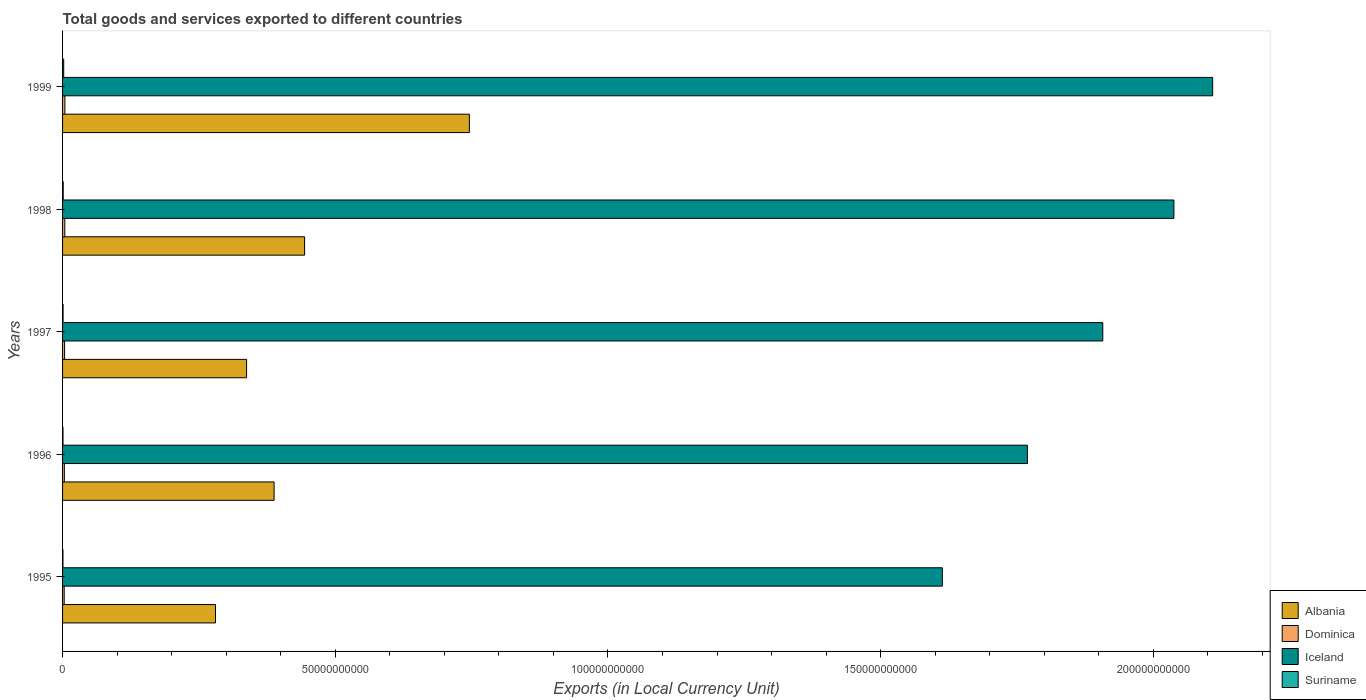How many different coloured bars are there?
Your answer should be very brief. 4. How many groups of bars are there?
Give a very brief answer. 5. Are the number of bars per tick equal to the number of legend labels?
Ensure brevity in your answer.  Yes. How many bars are there on the 3rd tick from the top?
Offer a very short reply. 4. What is the label of the 2nd group of bars from the top?
Your answer should be very brief. 1998. In how many cases, is the number of bars for a given year not equal to the number of legend labels?
Your response must be concise. 0. What is the Amount of goods and services exports in Suriname in 1999?
Provide a succinct answer. 2.07e+08. Across all years, what is the maximum Amount of goods and services exports in Dominica?
Keep it short and to the point. 4.23e+08. Across all years, what is the minimum Amount of goods and services exports in Suriname?
Your answer should be compact. 7.01e+07. In which year was the Amount of goods and services exports in Albania minimum?
Give a very brief answer. 1995. What is the total Amount of goods and services exports in Suriname in the graph?
Keep it short and to the point. 5.69e+08. What is the difference between the Amount of goods and services exports in Albania in 1998 and that in 1999?
Ensure brevity in your answer.  -3.02e+1. What is the difference between the Amount of goods and services exports in Dominica in 1996 and the Amount of goods and services exports in Suriname in 1995?
Give a very brief answer. 2.58e+08. What is the average Amount of goods and services exports in Albania per year?
Keep it short and to the point. 4.39e+1. In the year 1998, what is the difference between the Amount of goods and services exports in Suriname and Amount of goods and services exports in Iceland?
Make the answer very short. -2.04e+11. In how many years, is the Amount of goods and services exports in Albania greater than 170000000000 LCU?
Offer a terse response. 0. What is the ratio of the Amount of goods and services exports in Suriname in 1995 to that in 1997?
Keep it short and to the point. 0.75. Is the Amount of goods and services exports in Iceland in 1996 less than that in 1999?
Your answer should be compact. Yes. What is the difference between the highest and the second highest Amount of goods and services exports in Dominica?
Give a very brief answer. 1.41e+07. What is the difference between the highest and the lowest Amount of goods and services exports in Suriname?
Keep it short and to the point. 1.37e+08. In how many years, is the Amount of goods and services exports in Iceland greater than the average Amount of goods and services exports in Iceland taken over all years?
Your answer should be compact. 3. Is it the case that in every year, the sum of the Amount of goods and services exports in Suriname and Amount of goods and services exports in Dominica is greater than the sum of Amount of goods and services exports in Albania and Amount of goods and services exports in Iceland?
Ensure brevity in your answer.  No. What does the 4th bar from the top in 1997 represents?
Your answer should be very brief. Albania. What does the 3rd bar from the bottom in 1996 represents?
Offer a very short reply. Iceland. Is it the case that in every year, the sum of the Amount of goods and services exports in Suriname and Amount of goods and services exports in Albania is greater than the Amount of goods and services exports in Dominica?
Offer a terse response. Yes. How many bars are there?
Provide a succinct answer. 20. Are all the bars in the graph horizontal?
Provide a short and direct response. Yes. What is the difference between two consecutive major ticks on the X-axis?
Give a very brief answer. 5.00e+1. Where does the legend appear in the graph?
Offer a very short reply. Bottom right. How many legend labels are there?
Offer a terse response. 4. What is the title of the graph?
Provide a short and direct response. Total goods and services exported to different countries. Does "Mauritius" appear as one of the legend labels in the graph?
Provide a succinct answer. No. What is the label or title of the X-axis?
Your response must be concise. Exports (in Local Currency Unit). What is the Exports (in Local Currency Unit) in Albania in 1995?
Make the answer very short. 2.80e+1. What is the Exports (in Local Currency Unit) of Dominica in 1995?
Make the answer very short. 3.01e+08. What is the Exports (in Local Currency Unit) of Iceland in 1995?
Give a very brief answer. 1.61e+11. What is the Exports (in Local Currency Unit) of Suriname in 1995?
Your response must be concise. 7.01e+07. What is the Exports (in Local Currency Unit) in Albania in 1996?
Give a very brief answer. 3.88e+1. What is the Exports (in Local Currency Unit) in Dominica in 1996?
Give a very brief answer. 3.28e+08. What is the Exports (in Local Currency Unit) in Iceland in 1996?
Offer a terse response. 1.77e+11. What is the Exports (in Local Currency Unit) in Suriname in 1996?
Provide a short and direct response. 8.06e+07. What is the Exports (in Local Currency Unit) in Albania in 1997?
Provide a short and direct response. 3.37e+1. What is the Exports (in Local Currency Unit) of Dominica in 1997?
Offer a terse response. 3.70e+08. What is the Exports (in Local Currency Unit) in Iceland in 1997?
Provide a succinct answer. 1.91e+11. What is the Exports (in Local Currency Unit) in Suriname in 1997?
Provide a succinct answer. 9.37e+07. What is the Exports (in Local Currency Unit) of Albania in 1998?
Your answer should be compact. 4.44e+1. What is the Exports (in Local Currency Unit) of Dominica in 1998?
Make the answer very short. 4.09e+08. What is the Exports (in Local Currency Unit) in Iceland in 1998?
Ensure brevity in your answer.  2.04e+11. What is the Exports (in Local Currency Unit) in Suriname in 1998?
Provide a succinct answer. 1.18e+08. What is the Exports (in Local Currency Unit) in Albania in 1999?
Your answer should be compact. 7.46e+1. What is the Exports (in Local Currency Unit) of Dominica in 1999?
Make the answer very short. 4.23e+08. What is the Exports (in Local Currency Unit) in Iceland in 1999?
Your answer should be compact. 2.11e+11. What is the Exports (in Local Currency Unit) in Suriname in 1999?
Ensure brevity in your answer.  2.07e+08. Across all years, what is the maximum Exports (in Local Currency Unit) in Albania?
Your answer should be very brief. 7.46e+1. Across all years, what is the maximum Exports (in Local Currency Unit) of Dominica?
Provide a short and direct response. 4.23e+08. Across all years, what is the maximum Exports (in Local Currency Unit) of Iceland?
Offer a very short reply. 2.11e+11. Across all years, what is the maximum Exports (in Local Currency Unit) of Suriname?
Make the answer very short. 2.07e+08. Across all years, what is the minimum Exports (in Local Currency Unit) in Albania?
Offer a terse response. 2.80e+1. Across all years, what is the minimum Exports (in Local Currency Unit) in Dominica?
Give a very brief answer. 3.01e+08. Across all years, what is the minimum Exports (in Local Currency Unit) in Iceland?
Offer a terse response. 1.61e+11. Across all years, what is the minimum Exports (in Local Currency Unit) in Suriname?
Your answer should be compact. 7.01e+07. What is the total Exports (in Local Currency Unit) in Albania in the graph?
Keep it short and to the point. 2.20e+11. What is the total Exports (in Local Currency Unit) of Dominica in the graph?
Give a very brief answer. 1.83e+09. What is the total Exports (in Local Currency Unit) in Iceland in the graph?
Give a very brief answer. 9.44e+11. What is the total Exports (in Local Currency Unit) of Suriname in the graph?
Your answer should be very brief. 5.69e+08. What is the difference between the Exports (in Local Currency Unit) in Albania in 1995 and that in 1996?
Ensure brevity in your answer.  -1.07e+1. What is the difference between the Exports (in Local Currency Unit) of Dominica in 1995 and that in 1996?
Your answer should be compact. -2.65e+07. What is the difference between the Exports (in Local Currency Unit) in Iceland in 1995 and that in 1996?
Provide a short and direct response. -1.56e+1. What is the difference between the Exports (in Local Currency Unit) of Suriname in 1995 and that in 1996?
Keep it short and to the point. -1.05e+07. What is the difference between the Exports (in Local Currency Unit) of Albania in 1995 and that in 1997?
Keep it short and to the point. -5.70e+09. What is the difference between the Exports (in Local Currency Unit) of Dominica in 1995 and that in 1997?
Provide a short and direct response. -6.90e+07. What is the difference between the Exports (in Local Currency Unit) of Iceland in 1995 and that in 1997?
Ensure brevity in your answer.  -2.94e+1. What is the difference between the Exports (in Local Currency Unit) of Suriname in 1995 and that in 1997?
Give a very brief answer. -2.36e+07. What is the difference between the Exports (in Local Currency Unit) in Albania in 1995 and that in 1998?
Your response must be concise. -1.63e+1. What is the difference between the Exports (in Local Currency Unit) in Dominica in 1995 and that in 1998?
Your answer should be very brief. -1.08e+08. What is the difference between the Exports (in Local Currency Unit) of Iceland in 1995 and that in 1998?
Keep it short and to the point. -4.25e+1. What is the difference between the Exports (in Local Currency Unit) in Suriname in 1995 and that in 1998?
Provide a short and direct response. -4.75e+07. What is the difference between the Exports (in Local Currency Unit) in Albania in 1995 and that in 1999?
Offer a very short reply. -4.66e+1. What is the difference between the Exports (in Local Currency Unit) of Dominica in 1995 and that in 1999?
Give a very brief answer. -1.22e+08. What is the difference between the Exports (in Local Currency Unit) of Iceland in 1995 and that in 1999?
Offer a very short reply. -4.96e+1. What is the difference between the Exports (in Local Currency Unit) of Suriname in 1995 and that in 1999?
Offer a very short reply. -1.37e+08. What is the difference between the Exports (in Local Currency Unit) in Albania in 1996 and that in 1997?
Your answer should be very brief. 5.04e+09. What is the difference between the Exports (in Local Currency Unit) of Dominica in 1996 and that in 1997?
Give a very brief answer. -4.25e+07. What is the difference between the Exports (in Local Currency Unit) in Iceland in 1996 and that in 1997?
Offer a very short reply. -1.38e+1. What is the difference between the Exports (in Local Currency Unit) in Suriname in 1996 and that in 1997?
Make the answer very short. -1.31e+07. What is the difference between the Exports (in Local Currency Unit) in Albania in 1996 and that in 1998?
Your answer should be very brief. -5.59e+09. What is the difference between the Exports (in Local Currency Unit) in Dominica in 1996 and that in 1998?
Offer a very short reply. -8.16e+07. What is the difference between the Exports (in Local Currency Unit) in Iceland in 1996 and that in 1998?
Provide a succinct answer. -2.69e+1. What is the difference between the Exports (in Local Currency Unit) of Suriname in 1996 and that in 1998?
Offer a very short reply. -3.70e+07. What is the difference between the Exports (in Local Currency Unit) in Albania in 1996 and that in 1999?
Your answer should be compact. -3.58e+1. What is the difference between the Exports (in Local Currency Unit) in Dominica in 1996 and that in 1999?
Keep it short and to the point. -9.56e+07. What is the difference between the Exports (in Local Currency Unit) in Iceland in 1996 and that in 1999?
Keep it short and to the point. -3.40e+1. What is the difference between the Exports (in Local Currency Unit) in Suriname in 1996 and that in 1999?
Your answer should be compact. -1.27e+08. What is the difference between the Exports (in Local Currency Unit) in Albania in 1997 and that in 1998?
Your answer should be compact. -1.06e+1. What is the difference between the Exports (in Local Currency Unit) of Dominica in 1997 and that in 1998?
Make the answer very short. -3.90e+07. What is the difference between the Exports (in Local Currency Unit) of Iceland in 1997 and that in 1998?
Provide a short and direct response. -1.30e+1. What is the difference between the Exports (in Local Currency Unit) in Suriname in 1997 and that in 1998?
Provide a short and direct response. -2.39e+07. What is the difference between the Exports (in Local Currency Unit) of Albania in 1997 and that in 1999?
Give a very brief answer. -4.08e+1. What is the difference between the Exports (in Local Currency Unit) of Dominica in 1997 and that in 1999?
Keep it short and to the point. -5.31e+07. What is the difference between the Exports (in Local Currency Unit) in Iceland in 1997 and that in 1999?
Offer a terse response. -2.02e+1. What is the difference between the Exports (in Local Currency Unit) in Suriname in 1997 and that in 1999?
Ensure brevity in your answer.  -1.14e+08. What is the difference between the Exports (in Local Currency Unit) in Albania in 1998 and that in 1999?
Ensure brevity in your answer.  -3.02e+1. What is the difference between the Exports (in Local Currency Unit) in Dominica in 1998 and that in 1999?
Keep it short and to the point. -1.41e+07. What is the difference between the Exports (in Local Currency Unit) in Iceland in 1998 and that in 1999?
Make the answer very short. -7.11e+09. What is the difference between the Exports (in Local Currency Unit) in Suriname in 1998 and that in 1999?
Offer a very short reply. -8.98e+07. What is the difference between the Exports (in Local Currency Unit) of Albania in 1995 and the Exports (in Local Currency Unit) of Dominica in 1996?
Your answer should be very brief. 2.77e+1. What is the difference between the Exports (in Local Currency Unit) in Albania in 1995 and the Exports (in Local Currency Unit) in Iceland in 1996?
Ensure brevity in your answer.  -1.49e+11. What is the difference between the Exports (in Local Currency Unit) in Albania in 1995 and the Exports (in Local Currency Unit) in Suriname in 1996?
Make the answer very short. 2.80e+1. What is the difference between the Exports (in Local Currency Unit) of Dominica in 1995 and the Exports (in Local Currency Unit) of Iceland in 1996?
Your answer should be compact. -1.77e+11. What is the difference between the Exports (in Local Currency Unit) of Dominica in 1995 and the Exports (in Local Currency Unit) of Suriname in 1996?
Your response must be concise. 2.21e+08. What is the difference between the Exports (in Local Currency Unit) of Iceland in 1995 and the Exports (in Local Currency Unit) of Suriname in 1996?
Provide a succinct answer. 1.61e+11. What is the difference between the Exports (in Local Currency Unit) in Albania in 1995 and the Exports (in Local Currency Unit) in Dominica in 1997?
Ensure brevity in your answer.  2.77e+1. What is the difference between the Exports (in Local Currency Unit) of Albania in 1995 and the Exports (in Local Currency Unit) of Iceland in 1997?
Offer a very short reply. -1.63e+11. What is the difference between the Exports (in Local Currency Unit) of Albania in 1995 and the Exports (in Local Currency Unit) of Suriname in 1997?
Your answer should be very brief. 2.79e+1. What is the difference between the Exports (in Local Currency Unit) of Dominica in 1995 and the Exports (in Local Currency Unit) of Iceland in 1997?
Offer a terse response. -1.90e+11. What is the difference between the Exports (in Local Currency Unit) of Dominica in 1995 and the Exports (in Local Currency Unit) of Suriname in 1997?
Offer a terse response. 2.08e+08. What is the difference between the Exports (in Local Currency Unit) of Iceland in 1995 and the Exports (in Local Currency Unit) of Suriname in 1997?
Offer a very short reply. 1.61e+11. What is the difference between the Exports (in Local Currency Unit) of Albania in 1995 and the Exports (in Local Currency Unit) of Dominica in 1998?
Provide a short and direct response. 2.76e+1. What is the difference between the Exports (in Local Currency Unit) of Albania in 1995 and the Exports (in Local Currency Unit) of Iceland in 1998?
Offer a terse response. -1.76e+11. What is the difference between the Exports (in Local Currency Unit) of Albania in 1995 and the Exports (in Local Currency Unit) of Suriname in 1998?
Provide a succinct answer. 2.79e+1. What is the difference between the Exports (in Local Currency Unit) of Dominica in 1995 and the Exports (in Local Currency Unit) of Iceland in 1998?
Make the answer very short. -2.03e+11. What is the difference between the Exports (in Local Currency Unit) in Dominica in 1995 and the Exports (in Local Currency Unit) in Suriname in 1998?
Your response must be concise. 1.84e+08. What is the difference between the Exports (in Local Currency Unit) in Iceland in 1995 and the Exports (in Local Currency Unit) in Suriname in 1998?
Provide a succinct answer. 1.61e+11. What is the difference between the Exports (in Local Currency Unit) of Albania in 1995 and the Exports (in Local Currency Unit) of Dominica in 1999?
Offer a terse response. 2.76e+1. What is the difference between the Exports (in Local Currency Unit) in Albania in 1995 and the Exports (in Local Currency Unit) in Iceland in 1999?
Keep it short and to the point. -1.83e+11. What is the difference between the Exports (in Local Currency Unit) in Albania in 1995 and the Exports (in Local Currency Unit) in Suriname in 1999?
Offer a very short reply. 2.78e+1. What is the difference between the Exports (in Local Currency Unit) in Dominica in 1995 and the Exports (in Local Currency Unit) in Iceland in 1999?
Your response must be concise. -2.11e+11. What is the difference between the Exports (in Local Currency Unit) in Dominica in 1995 and the Exports (in Local Currency Unit) in Suriname in 1999?
Make the answer very short. 9.40e+07. What is the difference between the Exports (in Local Currency Unit) of Iceland in 1995 and the Exports (in Local Currency Unit) of Suriname in 1999?
Your response must be concise. 1.61e+11. What is the difference between the Exports (in Local Currency Unit) in Albania in 1996 and the Exports (in Local Currency Unit) in Dominica in 1997?
Give a very brief answer. 3.84e+1. What is the difference between the Exports (in Local Currency Unit) in Albania in 1996 and the Exports (in Local Currency Unit) in Iceland in 1997?
Your response must be concise. -1.52e+11. What is the difference between the Exports (in Local Currency Unit) in Albania in 1996 and the Exports (in Local Currency Unit) in Suriname in 1997?
Provide a succinct answer. 3.87e+1. What is the difference between the Exports (in Local Currency Unit) in Dominica in 1996 and the Exports (in Local Currency Unit) in Iceland in 1997?
Provide a succinct answer. -1.90e+11. What is the difference between the Exports (in Local Currency Unit) of Dominica in 1996 and the Exports (in Local Currency Unit) of Suriname in 1997?
Make the answer very short. 2.34e+08. What is the difference between the Exports (in Local Currency Unit) of Iceland in 1996 and the Exports (in Local Currency Unit) of Suriname in 1997?
Make the answer very short. 1.77e+11. What is the difference between the Exports (in Local Currency Unit) in Albania in 1996 and the Exports (in Local Currency Unit) in Dominica in 1998?
Give a very brief answer. 3.84e+1. What is the difference between the Exports (in Local Currency Unit) in Albania in 1996 and the Exports (in Local Currency Unit) in Iceland in 1998?
Ensure brevity in your answer.  -1.65e+11. What is the difference between the Exports (in Local Currency Unit) of Albania in 1996 and the Exports (in Local Currency Unit) of Suriname in 1998?
Your response must be concise. 3.87e+1. What is the difference between the Exports (in Local Currency Unit) in Dominica in 1996 and the Exports (in Local Currency Unit) in Iceland in 1998?
Your answer should be compact. -2.03e+11. What is the difference between the Exports (in Local Currency Unit) in Dominica in 1996 and the Exports (in Local Currency Unit) in Suriname in 1998?
Your response must be concise. 2.10e+08. What is the difference between the Exports (in Local Currency Unit) of Iceland in 1996 and the Exports (in Local Currency Unit) of Suriname in 1998?
Ensure brevity in your answer.  1.77e+11. What is the difference between the Exports (in Local Currency Unit) of Albania in 1996 and the Exports (in Local Currency Unit) of Dominica in 1999?
Keep it short and to the point. 3.84e+1. What is the difference between the Exports (in Local Currency Unit) of Albania in 1996 and the Exports (in Local Currency Unit) of Iceland in 1999?
Your answer should be very brief. -1.72e+11. What is the difference between the Exports (in Local Currency Unit) of Albania in 1996 and the Exports (in Local Currency Unit) of Suriname in 1999?
Provide a succinct answer. 3.86e+1. What is the difference between the Exports (in Local Currency Unit) in Dominica in 1996 and the Exports (in Local Currency Unit) in Iceland in 1999?
Provide a short and direct response. -2.11e+11. What is the difference between the Exports (in Local Currency Unit) of Dominica in 1996 and the Exports (in Local Currency Unit) of Suriname in 1999?
Give a very brief answer. 1.20e+08. What is the difference between the Exports (in Local Currency Unit) of Iceland in 1996 and the Exports (in Local Currency Unit) of Suriname in 1999?
Ensure brevity in your answer.  1.77e+11. What is the difference between the Exports (in Local Currency Unit) of Albania in 1997 and the Exports (in Local Currency Unit) of Dominica in 1998?
Provide a succinct answer. 3.33e+1. What is the difference between the Exports (in Local Currency Unit) of Albania in 1997 and the Exports (in Local Currency Unit) of Iceland in 1998?
Provide a short and direct response. -1.70e+11. What is the difference between the Exports (in Local Currency Unit) of Albania in 1997 and the Exports (in Local Currency Unit) of Suriname in 1998?
Give a very brief answer. 3.36e+1. What is the difference between the Exports (in Local Currency Unit) in Dominica in 1997 and the Exports (in Local Currency Unit) in Iceland in 1998?
Your response must be concise. -2.03e+11. What is the difference between the Exports (in Local Currency Unit) of Dominica in 1997 and the Exports (in Local Currency Unit) of Suriname in 1998?
Your answer should be compact. 2.53e+08. What is the difference between the Exports (in Local Currency Unit) in Iceland in 1997 and the Exports (in Local Currency Unit) in Suriname in 1998?
Keep it short and to the point. 1.91e+11. What is the difference between the Exports (in Local Currency Unit) of Albania in 1997 and the Exports (in Local Currency Unit) of Dominica in 1999?
Offer a terse response. 3.33e+1. What is the difference between the Exports (in Local Currency Unit) in Albania in 1997 and the Exports (in Local Currency Unit) in Iceland in 1999?
Ensure brevity in your answer.  -1.77e+11. What is the difference between the Exports (in Local Currency Unit) of Albania in 1997 and the Exports (in Local Currency Unit) of Suriname in 1999?
Provide a succinct answer. 3.35e+1. What is the difference between the Exports (in Local Currency Unit) of Dominica in 1997 and the Exports (in Local Currency Unit) of Iceland in 1999?
Make the answer very short. -2.10e+11. What is the difference between the Exports (in Local Currency Unit) of Dominica in 1997 and the Exports (in Local Currency Unit) of Suriname in 1999?
Your answer should be very brief. 1.63e+08. What is the difference between the Exports (in Local Currency Unit) of Iceland in 1997 and the Exports (in Local Currency Unit) of Suriname in 1999?
Provide a succinct answer. 1.91e+11. What is the difference between the Exports (in Local Currency Unit) in Albania in 1998 and the Exports (in Local Currency Unit) in Dominica in 1999?
Your response must be concise. 4.40e+1. What is the difference between the Exports (in Local Currency Unit) in Albania in 1998 and the Exports (in Local Currency Unit) in Iceland in 1999?
Provide a succinct answer. -1.66e+11. What is the difference between the Exports (in Local Currency Unit) of Albania in 1998 and the Exports (in Local Currency Unit) of Suriname in 1999?
Provide a short and direct response. 4.42e+1. What is the difference between the Exports (in Local Currency Unit) of Dominica in 1998 and the Exports (in Local Currency Unit) of Iceland in 1999?
Ensure brevity in your answer.  -2.10e+11. What is the difference between the Exports (in Local Currency Unit) of Dominica in 1998 and the Exports (in Local Currency Unit) of Suriname in 1999?
Ensure brevity in your answer.  2.02e+08. What is the difference between the Exports (in Local Currency Unit) of Iceland in 1998 and the Exports (in Local Currency Unit) of Suriname in 1999?
Ensure brevity in your answer.  2.04e+11. What is the average Exports (in Local Currency Unit) in Albania per year?
Give a very brief answer. 4.39e+1. What is the average Exports (in Local Currency Unit) of Dominica per year?
Provide a succinct answer. 3.66e+08. What is the average Exports (in Local Currency Unit) in Iceland per year?
Offer a very short reply. 1.89e+11. What is the average Exports (in Local Currency Unit) of Suriname per year?
Give a very brief answer. 1.14e+08. In the year 1995, what is the difference between the Exports (in Local Currency Unit) of Albania and Exports (in Local Currency Unit) of Dominica?
Provide a short and direct response. 2.77e+1. In the year 1995, what is the difference between the Exports (in Local Currency Unit) in Albania and Exports (in Local Currency Unit) in Iceland?
Your answer should be compact. -1.33e+11. In the year 1995, what is the difference between the Exports (in Local Currency Unit) of Albania and Exports (in Local Currency Unit) of Suriname?
Your response must be concise. 2.80e+1. In the year 1995, what is the difference between the Exports (in Local Currency Unit) of Dominica and Exports (in Local Currency Unit) of Iceland?
Keep it short and to the point. -1.61e+11. In the year 1995, what is the difference between the Exports (in Local Currency Unit) in Dominica and Exports (in Local Currency Unit) in Suriname?
Provide a succinct answer. 2.31e+08. In the year 1995, what is the difference between the Exports (in Local Currency Unit) of Iceland and Exports (in Local Currency Unit) of Suriname?
Give a very brief answer. 1.61e+11. In the year 1996, what is the difference between the Exports (in Local Currency Unit) of Albania and Exports (in Local Currency Unit) of Dominica?
Your answer should be very brief. 3.85e+1. In the year 1996, what is the difference between the Exports (in Local Currency Unit) of Albania and Exports (in Local Currency Unit) of Iceland?
Provide a succinct answer. -1.38e+11. In the year 1996, what is the difference between the Exports (in Local Currency Unit) in Albania and Exports (in Local Currency Unit) in Suriname?
Offer a terse response. 3.87e+1. In the year 1996, what is the difference between the Exports (in Local Currency Unit) in Dominica and Exports (in Local Currency Unit) in Iceland?
Offer a terse response. -1.77e+11. In the year 1996, what is the difference between the Exports (in Local Currency Unit) of Dominica and Exports (in Local Currency Unit) of Suriname?
Provide a short and direct response. 2.47e+08. In the year 1996, what is the difference between the Exports (in Local Currency Unit) of Iceland and Exports (in Local Currency Unit) of Suriname?
Your answer should be compact. 1.77e+11. In the year 1997, what is the difference between the Exports (in Local Currency Unit) of Albania and Exports (in Local Currency Unit) of Dominica?
Give a very brief answer. 3.34e+1. In the year 1997, what is the difference between the Exports (in Local Currency Unit) of Albania and Exports (in Local Currency Unit) of Iceland?
Provide a short and direct response. -1.57e+11. In the year 1997, what is the difference between the Exports (in Local Currency Unit) in Albania and Exports (in Local Currency Unit) in Suriname?
Offer a terse response. 3.36e+1. In the year 1997, what is the difference between the Exports (in Local Currency Unit) in Dominica and Exports (in Local Currency Unit) in Iceland?
Ensure brevity in your answer.  -1.90e+11. In the year 1997, what is the difference between the Exports (in Local Currency Unit) of Dominica and Exports (in Local Currency Unit) of Suriname?
Your response must be concise. 2.77e+08. In the year 1997, what is the difference between the Exports (in Local Currency Unit) in Iceland and Exports (in Local Currency Unit) in Suriname?
Offer a terse response. 1.91e+11. In the year 1998, what is the difference between the Exports (in Local Currency Unit) in Albania and Exports (in Local Currency Unit) in Dominica?
Offer a very short reply. 4.40e+1. In the year 1998, what is the difference between the Exports (in Local Currency Unit) of Albania and Exports (in Local Currency Unit) of Iceland?
Your answer should be compact. -1.59e+11. In the year 1998, what is the difference between the Exports (in Local Currency Unit) in Albania and Exports (in Local Currency Unit) in Suriname?
Provide a short and direct response. 4.43e+1. In the year 1998, what is the difference between the Exports (in Local Currency Unit) in Dominica and Exports (in Local Currency Unit) in Iceland?
Your answer should be very brief. -2.03e+11. In the year 1998, what is the difference between the Exports (in Local Currency Unit) in Dominica and Exports (in Local Currency Unit) in Suriname?
Provide a short and direct response. 2.92e+08. In the year 1998, what is the difference between the Exports (in Local Currency Unit) of Iceland and Exports (in Local Currency Unit) of Suriname?
Your response must be concise. 2.04e+11. In the year 1999, what is the difference between the Exports (in Local Currency Unit) in Albania and Exports (in Local Currency Unit) in Dominica?
Your answer should be very brief. 7.42e+1. In the year 1999, what is the difference between the Exports (in Local Currency Unit) of Albania and Exports (in Local Currency Unit) of Iceland?
Make the answer very short. -1.36e+11. In the year 1999, what is the difference between the Exports (in Local Currency Unit) of Albania and Exports (in Local Currency Unit) of Suriname?
Your response must be concise. 7.44e+1. In the year 1999, what is the difference between the Exports (in Local Currency Unit) of Dominica and Exports (in Local Currency Unit) of Iceland?
Offer a terse response. -2.10e+11. In the year 1999, what is the difference between the Exports (in Local Currency Unit) in Dominica and Exports (in Local Currency Unit) in Suriname?
Provide a short and direct response. 2.16e+08. In the year 1999, what is the difference between the Exports (in Local Currency Unit) in Iceland and Exports (in Local Currency Unit) in Suriname?
Ensure brevity in your answer.  2.11e+11. What is the ratio of the Exports (in Local Currency Unit) of Albania in 1995 to that in 1996?
Your response must be concise. 0.72. What is the ratio of the Exports (in Local Currency Unit) of Dominica in 1995 to that in 1996?
Your answer should be compact. 0.92. What is the ratio of the Exports (in Local Currency Unit) of Iceland in 1995 to that in 1996?
Your answer should be compact. 0.91. What is the ratio of the Exports (in Local Currency Unit) of Suriname in 1995 to that in 1996?
Offer a terse response. 0.87. What is the ratio of the Exports (in Local Currency Unit) of Albania in 1995 to that in 1997?
Keep it short and to the point. 0.83. What is the ratio of the Exports (in Local Currency Unit) in Dominica in 1995 to that in 1997?
Your response must be concise. 0.81. What is the ratio of the Exports (in Local Currency Unit) of Iceland in 1995 to that in 1997?
Offer a terse response. 0.85. What is the ratio of the Exports (in Local Currency Unit) of Suriname in 1995 to that in 1997?
Your answer should be compact. 0.75. What is the ratio of the Exports (in Local Currency Unit) in Albania in 1995 to that in 1998?
Make the answer very short. 0.63. What is the ratio of the Exports (in Local Currency Unit) of Dominica in 1995 to that in 1998?
Offer a very short reply. 0.74. What is the ratio of the Exports (in Local Currency Unit) in Iceland in 1995 to that in 1998?
Provide a short and direct response. 0.79. What is the ratio of the Exports (in Local Currency Unit) of Suriname in 1995 to that in 1998?
Offer a terse response. 0.6. What is the ratio of the Exports (in Local Currency Unit) in Albania in 1995 to that in 1999?
Give a very brief answer. 0.38. What is the ratio of the Exports (in Local Currency Unit) in Dominica in 1995 to that in 1999?
Keep it short and to the point. 0.71. What is the ratio of the Exports (in Local Currency Unit) of Iceland in 1995 to that in 1999?
Offer a very short reply. 0.77. What is the ratio of the Exports (in Local Currency Unit) of Suriname in 1995 to that in 1999?
Your response must be concise. 0.34. What is the ratio of the Exports (in Local Currency Unit) in Albania in 1996 to that in 1997?
Offer a very short reply. 1.15. What is the ratio of the Exports (in Local Currency Unit) of Dominica in 1996 to that in 1997?
Your answer should be compact. 0.89. What is the ratio of the Exports (in Local Currency Unit) of Iceland in 1996 to that in 1997?
Provide a short and direct response. 0.93. What is the ratio of the Exports (in Local Currency Unit) in Suriname in 1996 to that in 1997?
Your answer should be compact. 0.86. What is the ratio of the Exports (in Local Currency Unit) of Albania in 1996 to that in 1998?
Make the answer very short. 0.87. What is the ratio of the Exports (in Local Currency Unit) in Dominica in 1996 to that in 1998?
Offer a terse response. 0.8. What is the ratio of the Exports (in Local Currency Unit) in Iceland in 1996 to that in 1998?
Keep it short and to the point. 0.87. What is the ratio of the Exports (in Local Currency Unit) of Suriname in 1996 to that in 1998?
Ensure brevity in your answer.  0.69. What is the ratio of the Exports (in Local Currency Unit) of Albania in 1996 to that in 1999?
Give a very brief answer. 0.52. What is the ratio of the Exports (in Local Currency Unit) of Dominica in 1996 to that in 1999?
Provide a succinct answer. 0.77. What is the ratio of the Exports (in Local Currency Unit) in Iceland in 1996 to that in 1999?
Offer a very short reply. 0.84. What is the ratio of the Exports (in Local Currency Unit) of Suriname in 1996 to that in 1999?
Offer a terse response. 0.39. What is the ratio of the Exports (in Local Currency Unit) of Albania in 1997 to that in 1998?
Provide a succinct answer. 0.76. What is the ratio of the Exports (in Local Currency Unit) of Dominica in 1997 to that in 1998?
Provide a succinct answer. 0.9. What is the ratio of the Exports (in Local Currency Unit) in Iceland in 1997 to that in 1998?
Give a very brief answer. 0.94. What is the ratio of the Exports (in Local Currency Unit) in Suriname in 1997 to that in 1998?
Give a very brief answer. 0.8. What is the ratio of the Exports (in Local Currency Unit) in Albania in 1997 to that in 1999?
Provide a succinct answer. 0.45. What is the ratio of the Exports (in Local Currency Unit) of Dominica in 1997 to that in 1999?
Provide a succinct answer. 0.87. What is the ratio of the Exports (in Local Currency Unit) in Iceland in 1997 to that in 1999?
Make the answer very short. 0.9. What is the ratio of the Exports (in Local Currency Unit) in Suriname in 1997 to that in 1999?
Offer a very short reply. 0.45. What is the ratio of the Exports (in Local Currency Unit) of Albania in 1998 to that in 1999?
Provide a short and direct response. 0.59. What is the ratio of the Exports (in Local Currency Unit) in Dominica in 1998 to that in 1999?
Provide a short and direct response. 0.97. What is the ratio of the Exports (in Local Currency Unit) in Iceland in 1998 to that in 1999?
Ensure brevity in your answer.  0.97. What is the ratio of the Exports (in Local Currency Unit) of Suriname in 1998 to that in 1999?
Provide a short and direct response. 0.57. What is the difference between the highest and the second highest Exports (in Local Currency Unit) in Albania?
Offer a terse response. 3.02e+1. What is the difference between the highest and the second highest Exports (in Local Currency Unit) in Dominica?
Make the answer very short. 1.41e+07. What is the difference between the highest and the second highest Exports (in Local Currency Unit) in Iceland?
Keep it short and to the point. 7.11e+09. What is the difference between the highest and the second highest Exports (in Local Currency Unit) in Suriname?
Your answer should be very brief. 8.98e+07. What is the difference between the highest and the lowest Exports (in Local Currency Unit) of Albania?
Ensure brevity in your answer.  4.66e+1. What is the difference between the highest and the lowest Exports (in Local Currency Unit) in Dominica?
Your answer should be compact. 1.22e+08. What is the difference between the highest and the lowest Exports (in Local Currency Unit) in Iceland?
Make the answer very short. 4.96e+1. What is the difference between the highest and the lowest Exports (in Local Currency Unit) of Suriname?
Give a very brief answer. 1.37e+08. 